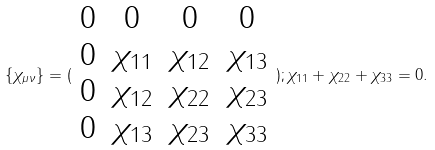<formula> <loc_0><loc_0><loc_500><loc_500>\{ \chi _ { \mu \nu } \} = ( \begin{array} { c c c c } 0 & 0 & 0 & 0 \\ 0 & \chi _ { 1 1 } & \chi _ { 1 2 } & \chi _ { 1 3 } \\ 0 & \chi _ { 1 2 } & \chi _ { 2 2 } & \chi _ { 2 3 } \\ 0 & \chi _ { 1 3 } & \chi _ { 2 3 } & \chi _ { 3 3 } \end{array} ) ; \chi _ { 1 1 } + \chi _ { 2 2 } + \chi _ { 3 3 } = 0 .</formula> 